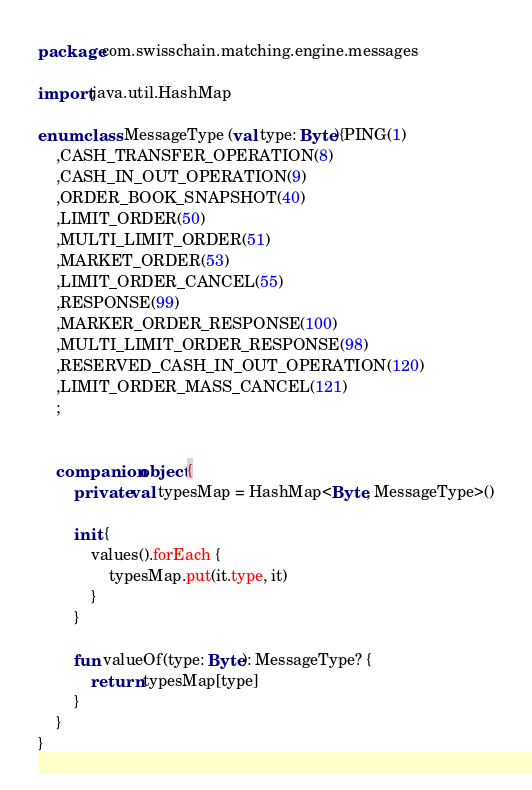<code> <loc_0><loc_0><loc_500><loc_500><_Kotlin_>package com.swisschain.matching.engine.messages

import java.util.HashMap

enum class MessageType (val type: Byte){PING(1)
    ,CASH_TRANSFER_OPERATION(8)
    ,CASH_IN_OUT_OPERATION(9)
    ,ORDER_BOOK_SNAPSHOT(40)
    ,LIMIT_ORDER(50)
    ,MULTI_LIMIT_ORDER(51)
    ,MARKET_ORDER(53)
    ,LIMIT_ORDER_CANCEL(55)
    ,RESPONSE(99)
    ,MARKER_ORDER_RESPONSE(100)
    ,MULTI_LIMIT_ORDER_RESPONSE(98)
    ,RESERVED_CASH_IN_OUT_OPERATION(120)
    ,LIMIT_ORDER_MASS_CANCEL(121)
    ;


    companion object {
        private val typesMap = HashMap<Byte, MessageType>()

        init {
            values().forEach {
                typesMap.put(it.type, it)
            }
        }

        fun valueOf(type: Byte): MessageType? {
            return typesMap[type]
        }
    }
}</code> 